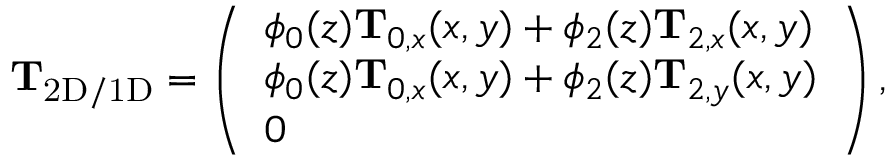<formula> <loc_0><loc_0><loc_500><loc_500>\begin{array} { r } { T _ { 2 D / 1 D } = \left ( \begin{array} { l } { \phi _ { 0 } ( z ) T _ { 0 , x } ( x , y ) + \phi _ { 2 } ( z ) T _ { 2 , x } ( x , y ) } \\ { \phi _ { 0 } ( z ) T _ { 0 , x } ( x , y ) + \phi _ { 2 } ( z ) T _ { 2 , y } ( x , y ) } \\ { 0 } \end{array} \right ) , } \end{array}</formula> 